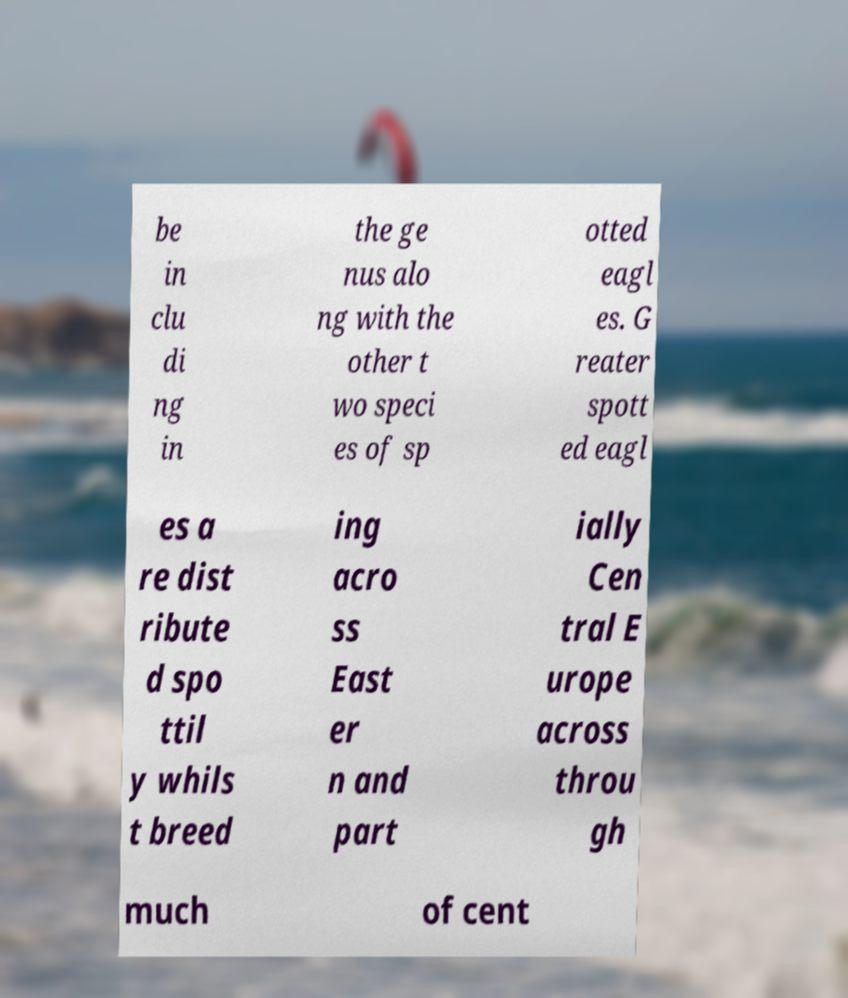Please read and relay the text visible in this image. What does it say? be in clu di ng in the ge nus alo ng with the other t wo speci es of sp otted eagl es. G reater spott ed eagl es a re dist ribute d spo ttil y whils t breed ing acro ss East er n and part ially Cen tral E urope across throu gh much of cent 